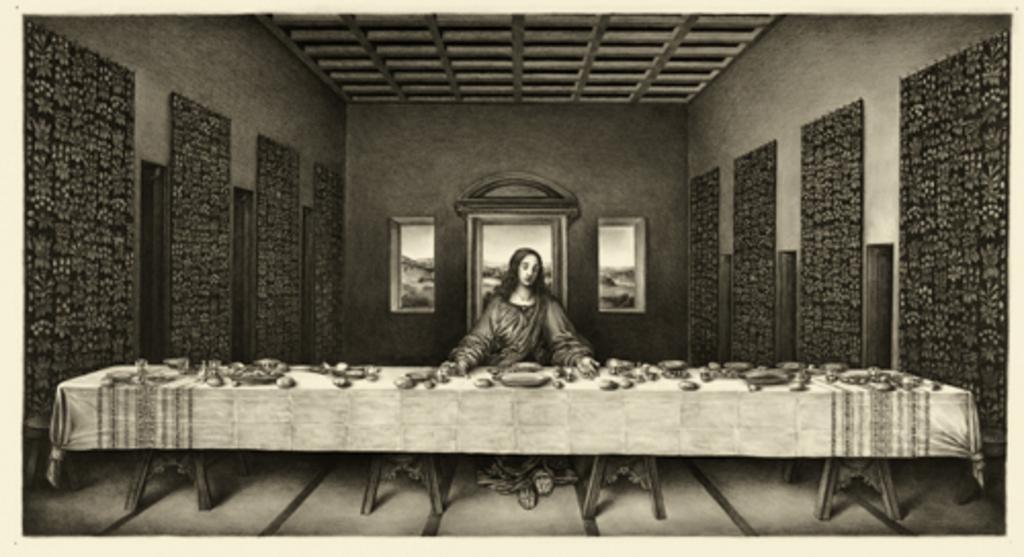How would you summarize this image in a sentence or two? In this image I can see a photo of a woman and a table. On the table I can see some objects. Here I can see ceiling and wall. This picture is black and white in color. 